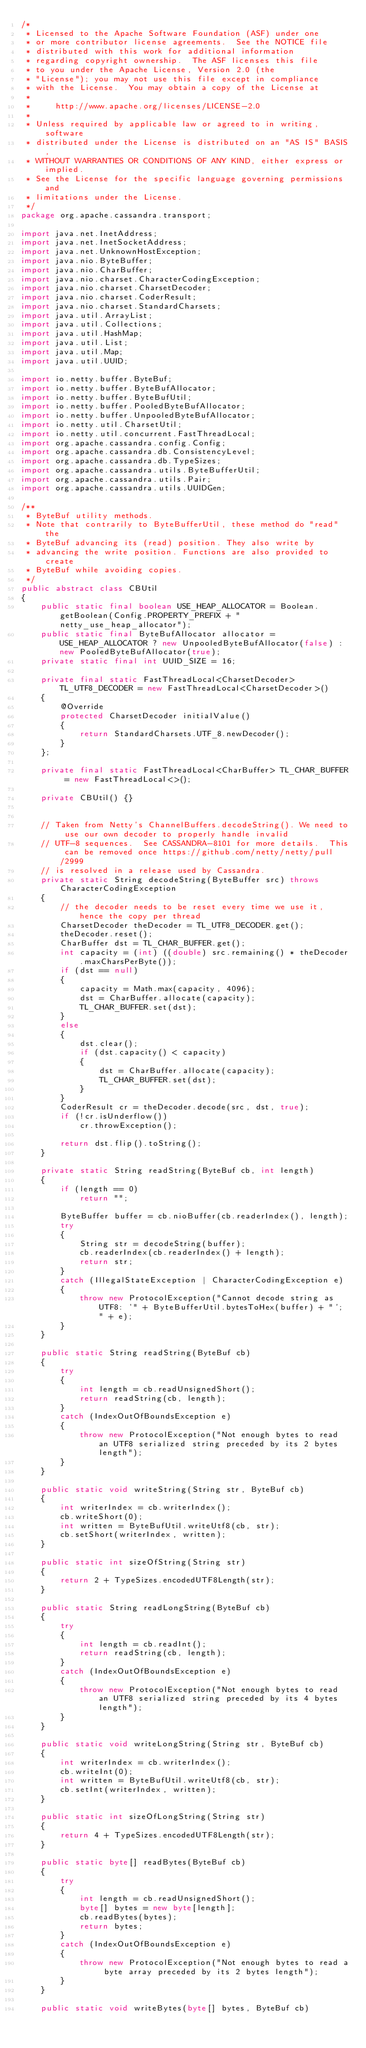<code> <loc_0><loc_0><loc_500><loc_500><_Java_>/*
 * Licensed to the Apache Software Foundation (ASF) under one
 * or more contributor license agreements.  See the NOTICE file
 * distributed with this work for additional information
 * regarding copyright ownership.  The ASF licenses this file
 * to you under the Apache License, Version 2.0 (the
 * "License"); you may not use this file except in compliance
 * with the License.  You may obtain a copy of the License at
 *
 *     http://www.apache.org/licenses/LICENSE-2.0
 *
 * Unless required by applicable law or agreed to in writing, software
 * distributed under the License is distributed on an "AS IS" BASIS,
 * WITHOUT WARRANTIES OR CONDITIONS OF ANY KIND, either express or implied.
 * See the License for the specific language governing permissions and
 * limitations under the License.
 */
package org.apache.cassandra.transport;

import java.net.InetAddress;
import java.net.InetSocketAddress;
import java.net.UnknownHostException;
import java.nio.ByteBuffer;
import java.nio.CharBuffer;
import java.nio.charset.CharacterCodingException;
import java.nio.charset.CharsetDecoder;
import java.nio.charset.CoderResult;
import java.nio.charset.StandardCharsets;
import java.util.ArrayList;
import java.util.Collections;
import java.util.HashMap;
import java.util.List;
import java.util.Map;
import java.util.UUID;

import io.netty.buffer.ByteBuf;
import io.netty.buffer.ByteBufAllocator;
import io.netty.buffer.ByteBufUtil;
import io.netty.buffer.PooledByteBufAllocator;
import io.netty.buffer.UnpooledByteBufAllocator;
import io.netty.util.CharsetUtil;
import io.netty.util.concurrent.FastThreadLocal;
import org.apache.cassandra.config.Config;
import org.apache.cassandra.db.ConsistencyLevel;
import org.apache.cassandra.db.TypeSizes;
import org.apache.cassandra.utils.ByteBufferUtil;
import org.apache.cassandra.utils.Pair;
import org.apache.cassandra.utils.UUIDGen;

/**
 * ByteBuf utility methods.
 * Note that contrarily to ByteBufferUtil, these method do "read" the
 * ByteBuf advancing its (read) position. They also write by
 * advancing the write position. Functions are also provided to create
 * ByteBuf while avoiding copies.
 */
public abstract class CBUtil
{
    public static final boolean USE_HEAP_ALLOCATOR = Boolean.getBoolean(Config.PROPERTY_PREFIX + "netty_use_heap_allocator");
    public static final ByteBufAllocator allocator = USE_HEAP_ALLOCATOR ? new UnpooledByteBufAllocator(false) : new PooledByteBufAllocator(true);
    private static final int UUID_SIZE = 16;

    private final static FastThreadLocal<CharsetDecoder> TL_UTF8_DECODER = new FastThreadLocal<CharsetDecoder>()
    {
        @Override
        protected CharsetDecoder initialValue()
        {
            return StandardCharsets.UTF_8.newDecoder();
        }
    };

    private final static FastThreadLocal<CharBuffer> TL_CHAR_BUFFER = new FastThreadLocal<>();

    private CBUtil() {}


    // Taken from Netty's ChannelBuffers.decodeString(). We need to use our own decoder to properly handle invalid
    // UTF-8 sequences.  See CASSANDRA-8101 for more details.  This can be removed once https://github.com/netty/netty/pull/2999
    // is resolved in a release used by Cassandra.
    private static String decodeString(ByteBuffer src) throws CharacterCodingException
    {
        // the decoder needs to be reset every time we use it, hence the copy per thread
        CharsetDecoder theDecoder = TL_UTF8_DECODER.get();
        theDecoder.reset();
        CharBuffer dst = TL_CHAR_BUFFER.get();
        int capacity = (int) ((double) src.remaining() * theDecoder.maxCharsPerByte());
        if (dst == null)
        {
            capacity = Math.max(capacity, 4096);
            dst = CharBuffer.allocate(capacity);
            TL_CHAR_BUFFER.set(dst);
        }
        else
        {
            dst.clear();
            if (dst.capacity() < capacity)
            {
                dst = CharBuffer.allocate(capacity);
                TL_CHAR_BUFFER.set(dst);
            }
        }
        CoderResult cr = theDecoder.decode(src, dst, true);
        if (!cr.isUnderflow())
            cr.throwException();

        return dst.flip().toString();
    }

    private static String readString(ByteBuf cb, int length)
    {
        if (length == 0)
            return "";

        ByteBuffer buffer = cb.nioBuffer(cb.readerIndex(), length);
        try
        {
            String str = decodeString(buffer);
            cb.readerIndex(cb.readerIndex() + length);
            return str;
        }
        catch (IllegalStateException | CharacterCodingException e)
        {
            throw new ProtocolException("Cannot decode string as UTF8: '" + ByteBufferUtil.bytesToHex(buffer) + "'; " + e);
        }
    }

    public static String readString(ByteBuf cb)
    {
        try
        {
            int length = cb.readUnsignedShort();
            return readString(cb, length);
        }
        catch (IndexOutOfBoundsException e)
        {
            throw new ProtocolException("Not enough bytes to read an UTF8 serialized string preceded by its 2 bytes length");
        }
    }

    public static void writeString(String str, ByteBuf cb)
    {
        int writerIndex = cb.writerIndex();
        cb.writeShort(0);
        int written = ByteBufUtil.writeUtf8(cb, str);
        cb.setShort(writerIndex, written);
    }

    public static int sizeOfString(String str)
    {
        return 2 + TypeSizes.encodedUTF8Length(str);
    }

    public static String readLongString(ByteBuf cb)
    {
        try
        {
            int length = cb.readInt();
            return readString(cb, length);
        }
        catch (IndexOutOfBoundsException e)
        {
            throw new ProtocolException("Not enough bytes to read an UTF8 serialized string preceded by its 4 bytes length");
        }
    }

    public static void writeLongString(String str, ByteBuf cb)
    {
        int writerIndex = cb.writerIndex();
        cb.writeInt(0);
        int written = ByteBufUtil.writeUtf8(cb, str);
        cb.setInt(writerIndex, written);
    }

    public static int sizeOfLongString(String str)
    {
        return 4 + TypeSizes.encodedUTF8Length(str);
    }

    public static byte[] readBytes(ByteBuf cb)
    {
        try
        {
            int length = cb.readUnsignedShort();
            byte[] bytes = new byte[length];
            cb.readBytes(bytes);
            return bytes;
        }
        catch (IndexOutOfBoundsException e)
        {
            throw new ProtocolException("Not enough bytes to read a byte array preceded by its 2 bytes length");
        }
    }

    public static void writeBytes(byte[] bytes, ByteBuf cb)</code> 